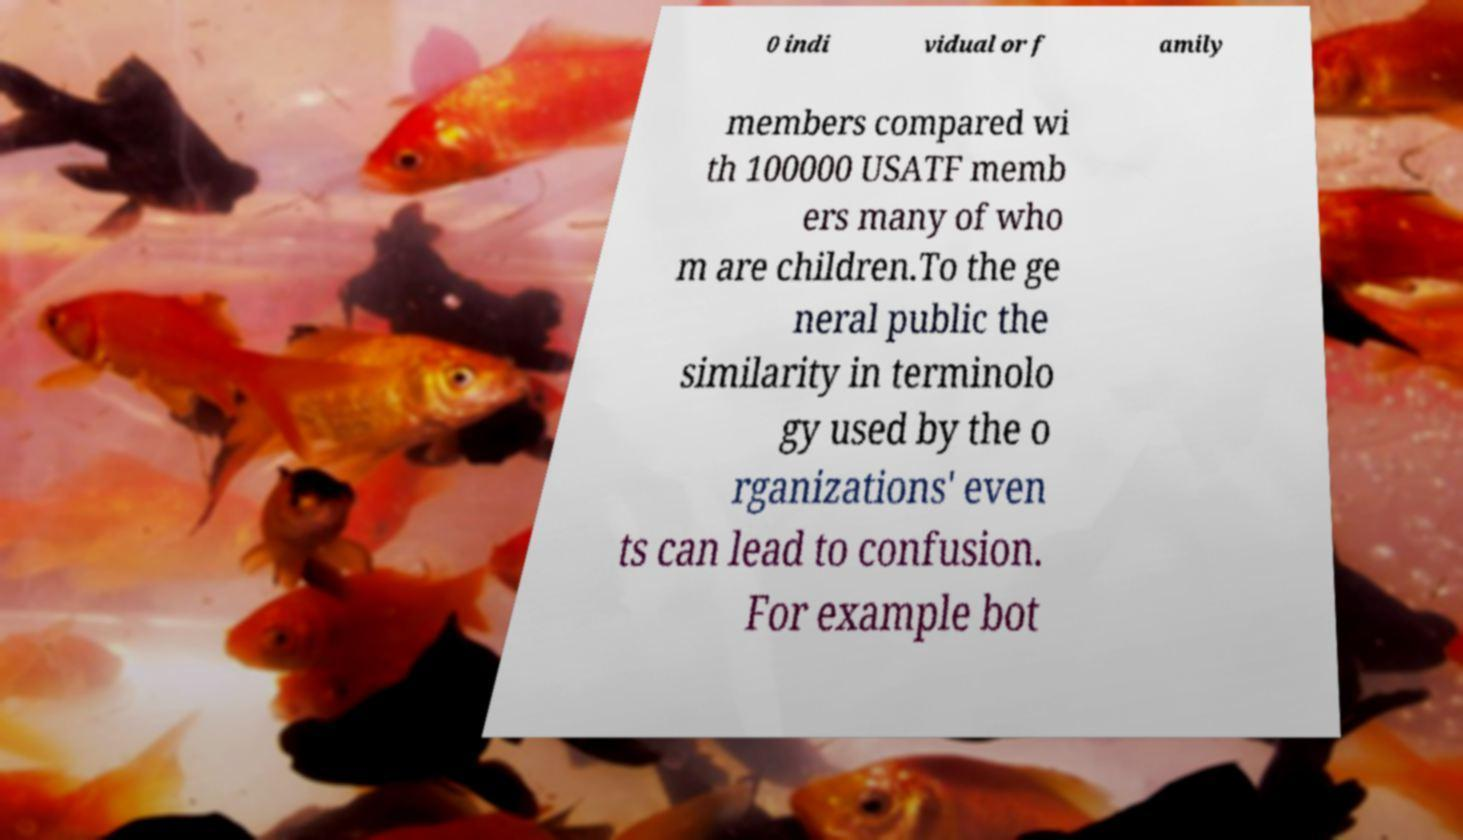Could you extract and type out the text from this image? 0 indi vidual or f amily members compared wi th 100000 USATF memb ers many of who m are children.To the ge neral public the similarity in terminolo gy used by the o rganizations' even ts can lead to confusion. For example bot 